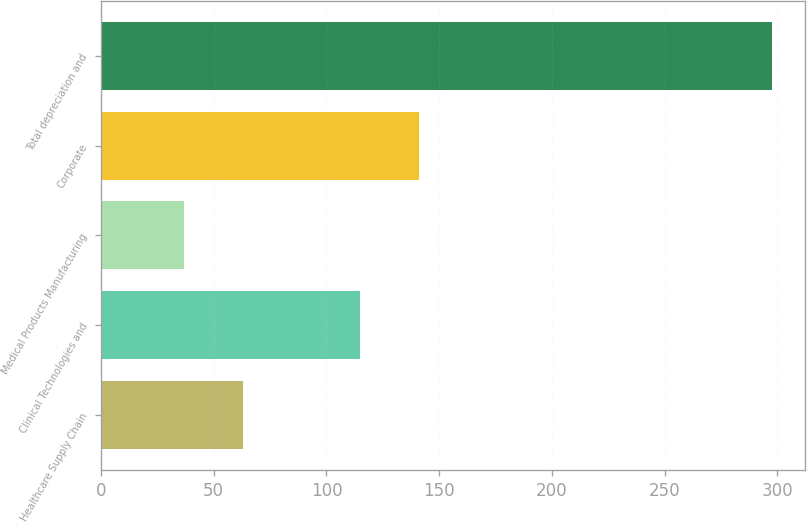<chart> <loc_0><loc_0><loc_500><loc_500><bar_chart><fcel>Healthcare Supply Chain<fcel>Clinical Technologies and<fcel>Medical Products Manufacturing<fcel>Corporate<fcel>Total depreciation and<nl><fcel>62.88<fcel>115.04<fcel>36.8<fcel>141.12<fcel>297.6<nl></chart> 